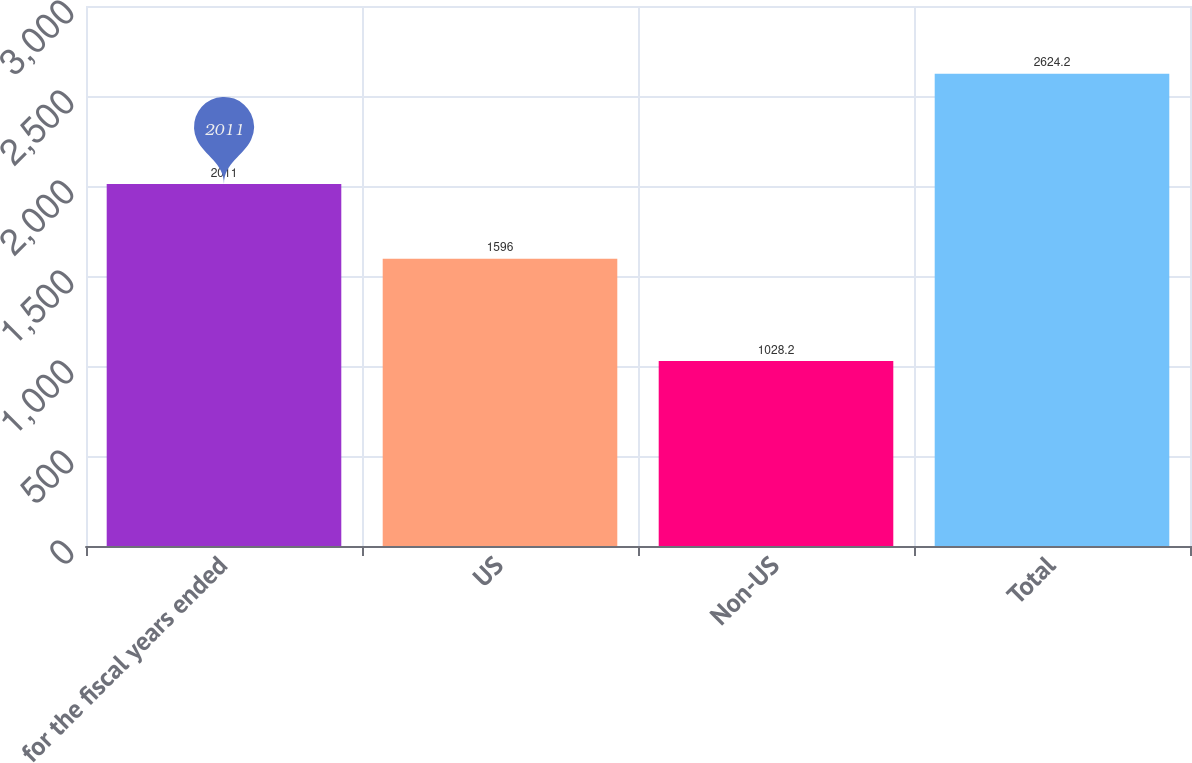<chart> <loc_0><loc_0><loc_500><loc_500><bar_chart><fcel>for the fiscal years ended<fcel>US<fcel>Non-US<fcel>Total<nl><fcel>2011<fcel>1596<fcel>1028.2<fcel>2624.2<nl></chart> 